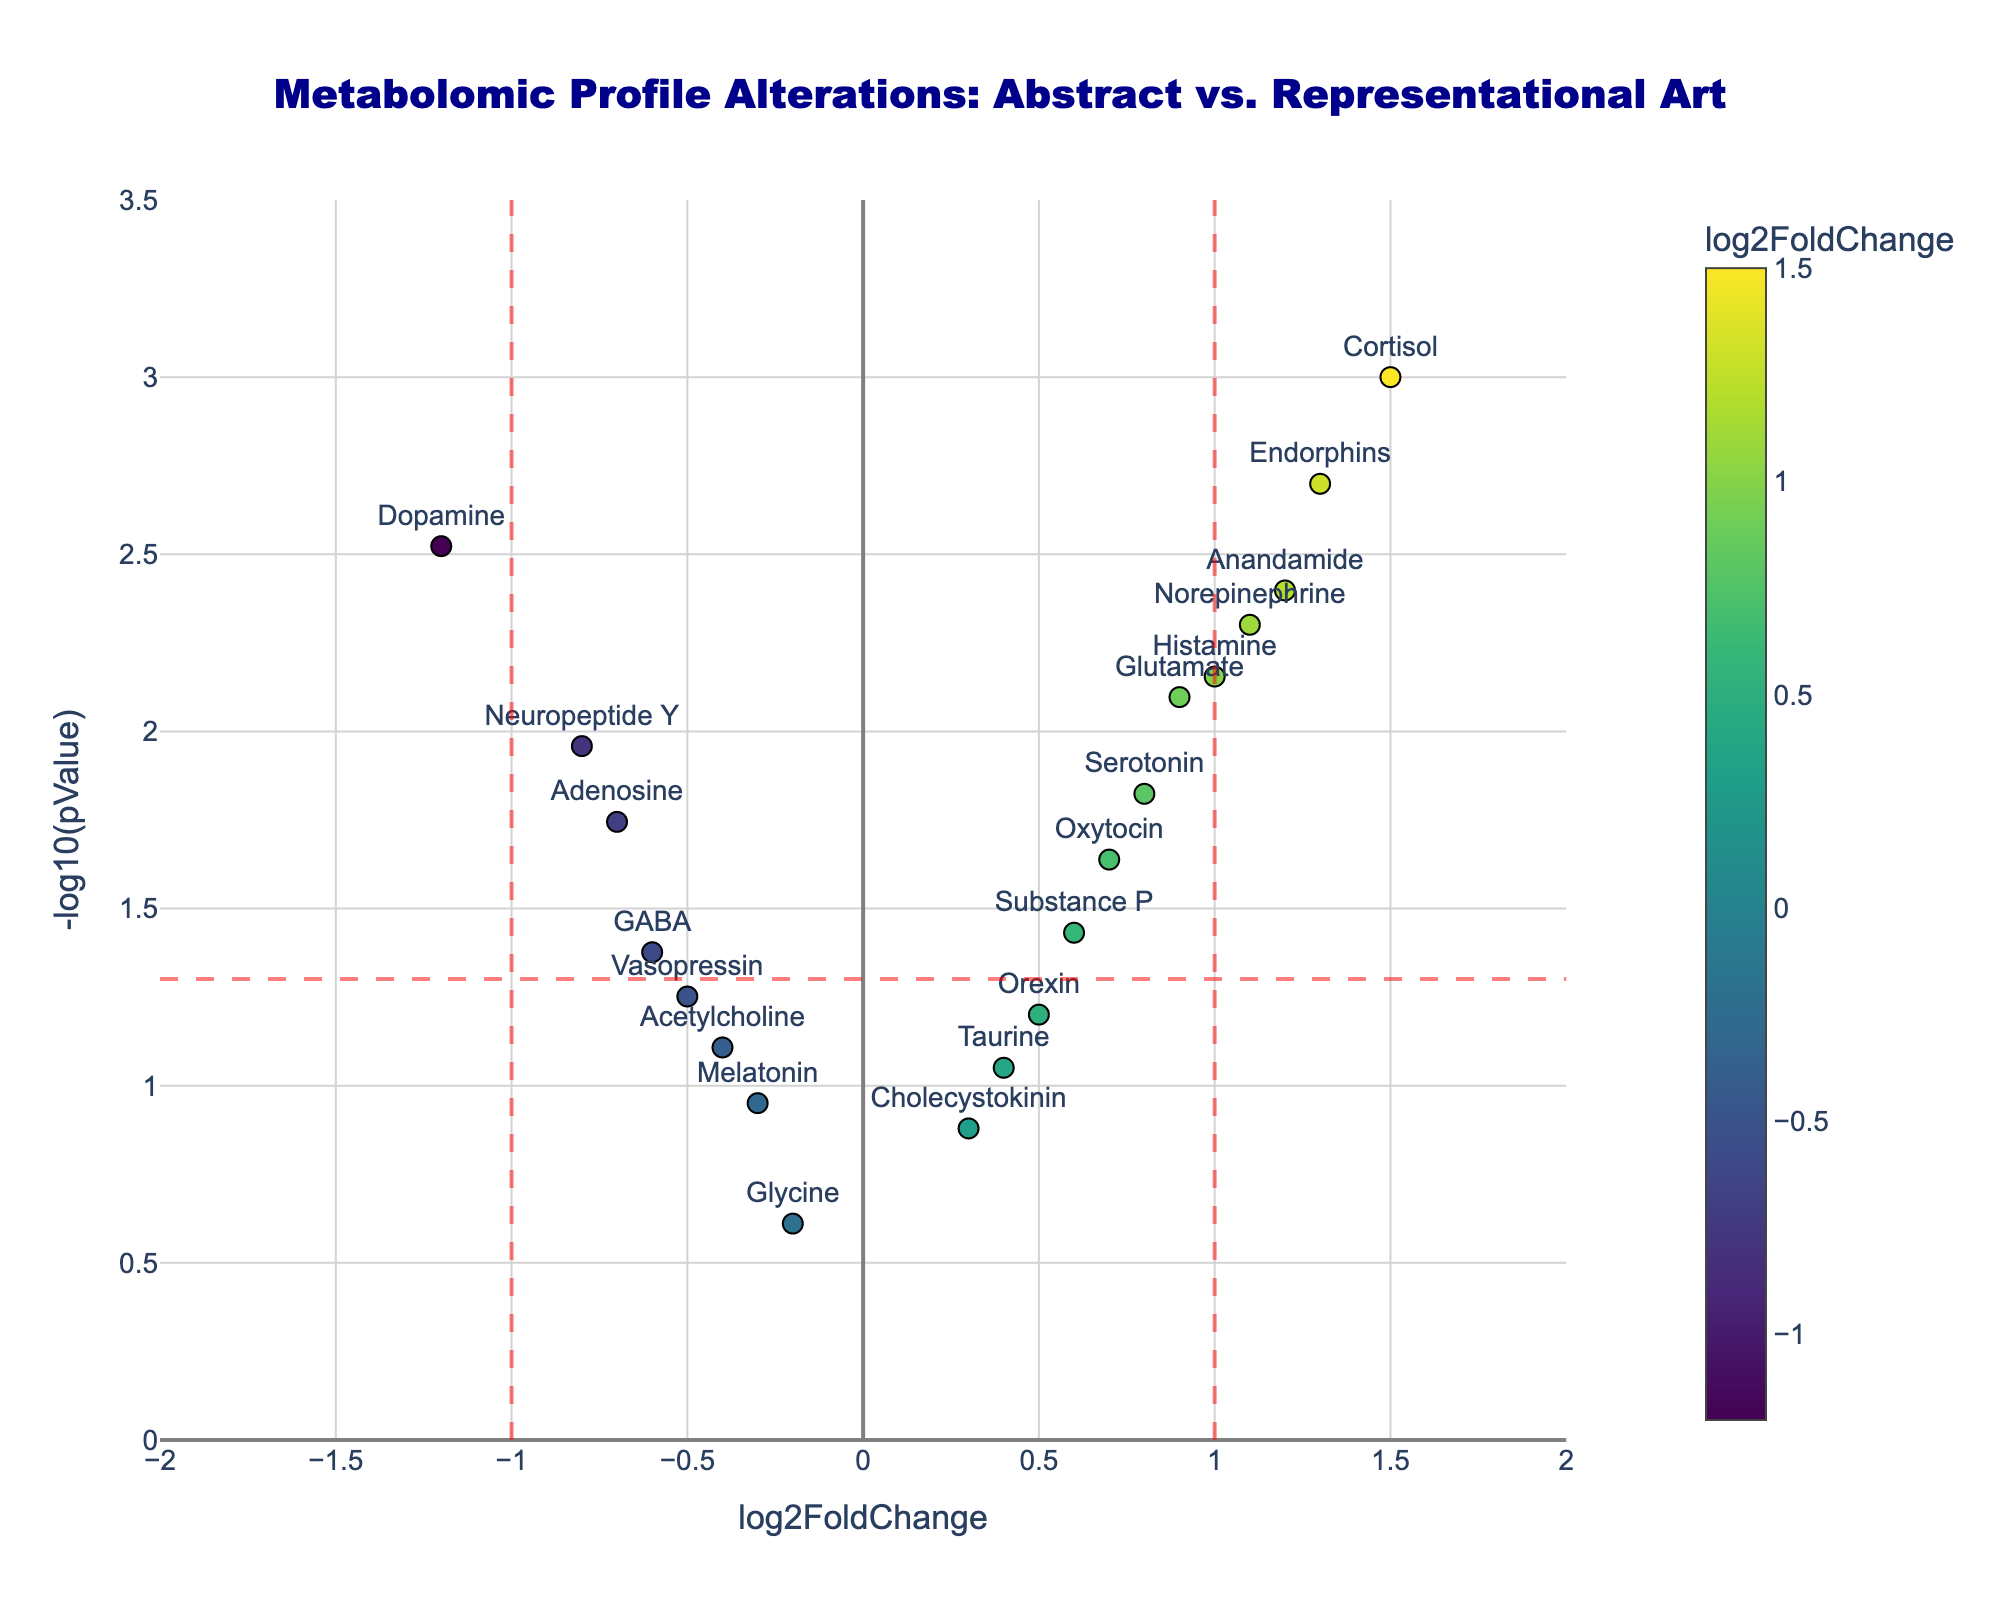How many metabolites are analyzed in the plot? Count the number of data points in the plot, each representing a different metabolite. There are 20 unique metabolites listed in the data.
Answer: 20 What is the color scale used to represent the log2FoldChange values? The color scale used is Viridis, which ranges from dark purple to bright yellow. This can be inferred by looking at the gradient colorbar on the right side of the plot.
Answer: Viridis Which metabolite shows the highest -log10(pValue)? Identify the data point located at the highest y-value on the plot. Endorphins are at the top with a -log10(pValue) approximately around 3.301.
Answer: Endorphins Which metabolite has a log2FoldChange close to 0 and a low -log10(pValue)? Look for a data point near the x=0 line with a relatively small y-value. Melatonin fits this description with a log2FoldChange of -0.3 and a -log10(pValue) lower than 1.
Answer: Melatonin What is the log2FoldChange value of Dopamine, and is it upregulated or downregulated? Find Dopamine on the plot and read its log2FoldChange value. Dopamine has a log2FoldChange of -1.2, which indicates it is downregulated.
Answer: -1.2, downregulated Which metabolites are considered significantly different at a p-value threshold of 0.05? Identify data points above the horizontal dashed red line, which corresponds to -log10(0.05) ≈ 1.301. This includes Endorphins, Cortisol, Histamine, Anandamide, Norepinephrine, Glutamate, Dopamine, Adenosine, and Serotonin.
Answer: 9 metabolites (Endorphins, Cortisol, Histamine, Anandamide, Norepinephrine, Glutamate, Dopamine, Adenosine, Serotonin) Compare the log2FoldChange values of Cortisol and GABA. Which one has a higher value? Locate both Cortisol and GABA on the x-axis and compare their log2FoldChange values. Cortisol has a log2FoldChange of 1.5, whereas GABA has -0.6, making Cortisol's value higher.
Answer: Cortisol Which metabolite had the largest absolute change in log2FoldChange values? Find the data point furthest from the x=0 line. Cortisol, with a log2FoldChange of 1.5, has the largest absolute change.
Answer: Cortisol Identify the metabolites that are both significantly different (p-value < 0.05) and have a log2FoldChange greater than 1. Look for data points above the dashed horizontal red line and to the right of the x=1 line. These are Cortisol, Endorphins, Anandamide, and Histamine.
Answer: Cortisol, Endorphins, Anandamide, Histamine 